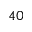Convert formula to latex. <formula><loc_0><loc_0><loc_500><loc_500>^ { 4 0 }</formula> 